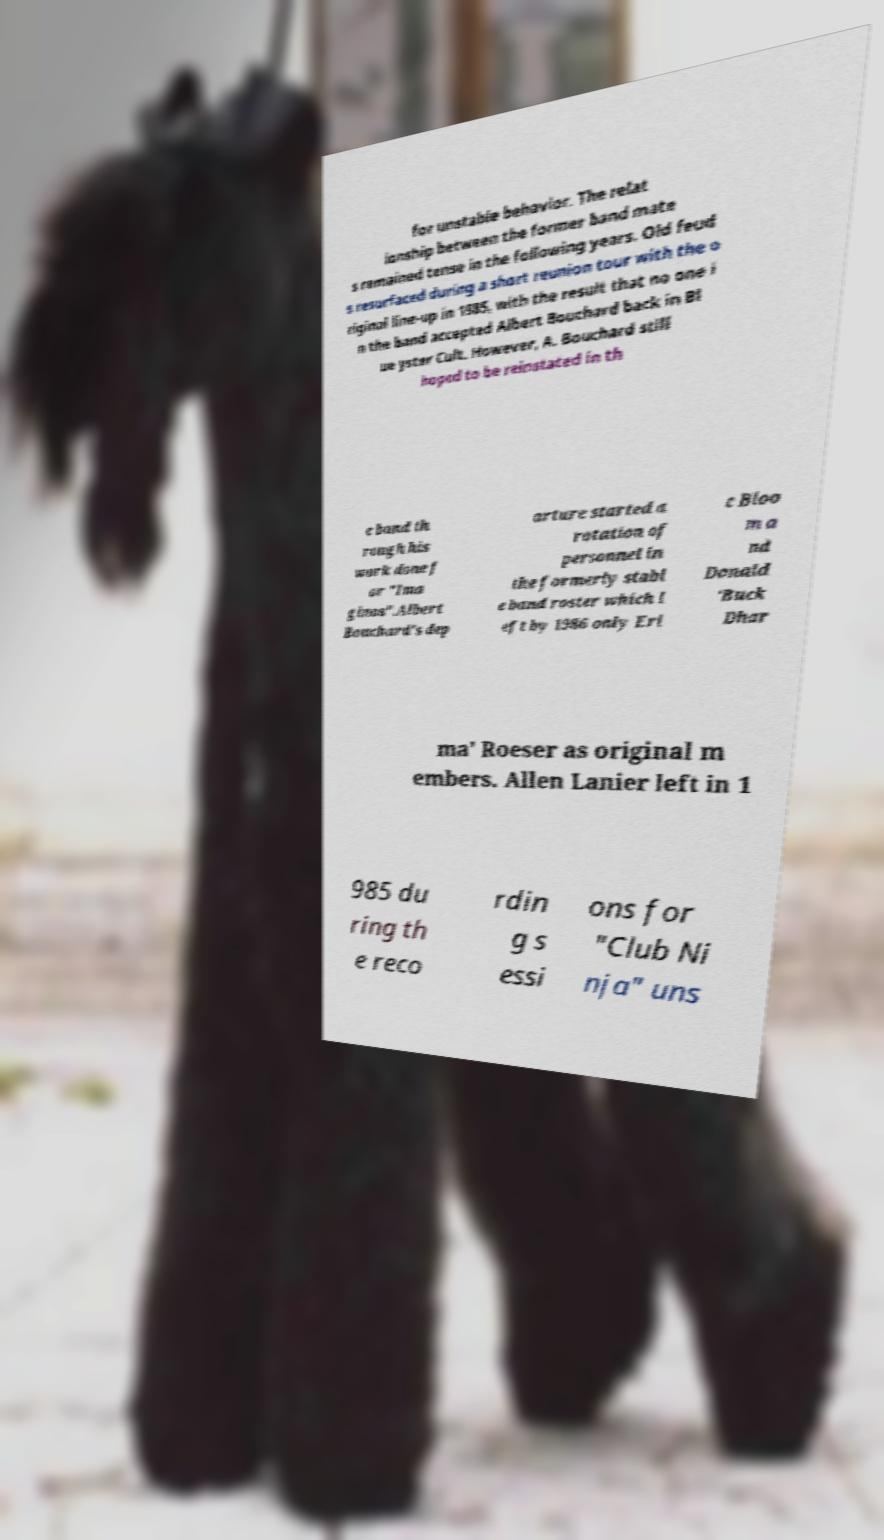Can you read and provide the text displayed in the image?This photo seems to have some interesting text. Can you extract and type it out for me? for unstable behavior. The relat ionship between the former band mate s remained tense in the following years. Old feud s resurfaced during a short reunion tour with the o riginal line-up in 1985, with the result that no one i n the band accepted Albert Bouchard back in Bl ue yster Cult. However, A. Bouchard still hoped to be reinstated in th e band th rough his work done f or "Ima ginos".Albert Bouchard's dep arture started a rotation of personnel in the formerly stabl e band roster which l eft by 1986 only Eri c Bloo m a nd Donald 'Buck Dhar ma' Roeser as original m embers. Allen Lanier left in 1 985 du ring th e reco rdin g s essi ons for "Club Ni nja" uns 